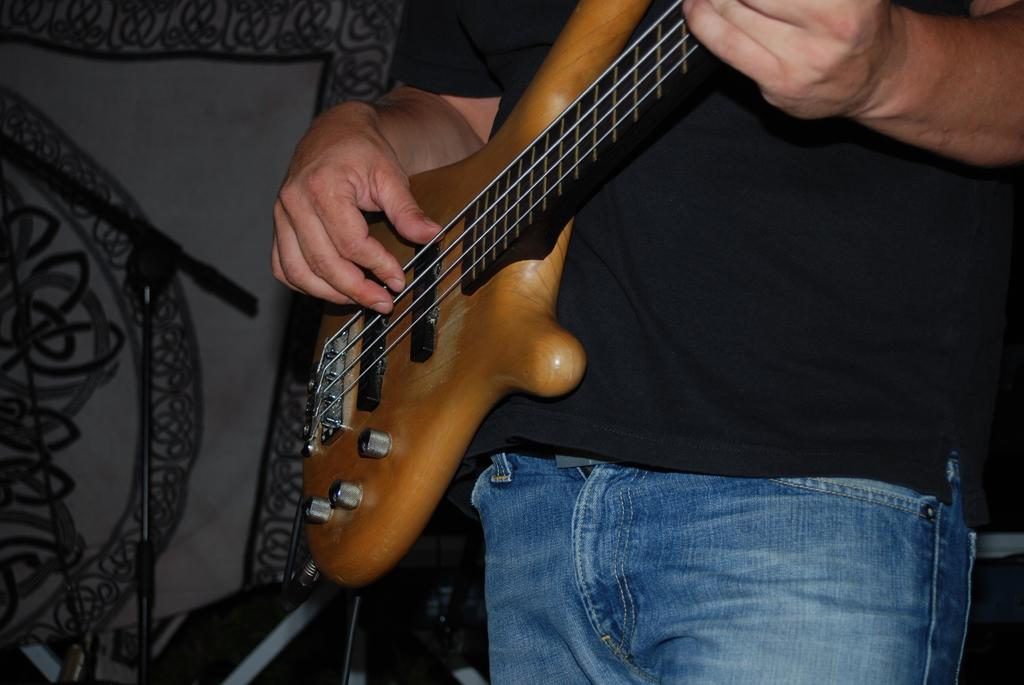What is the main subject of the image? There is a person in the image. What is the person doing in the image? The person is playing a guitar. What type of property is mentioned in the caption of the image? There is no caption present in the image, and therefore no property is mentioned. What role does milk play in the image? There is no milk present in the image, so it does not play any role. 